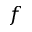<formula> <loc_0><loc_0><loc_500><loc_500>f</formula> 